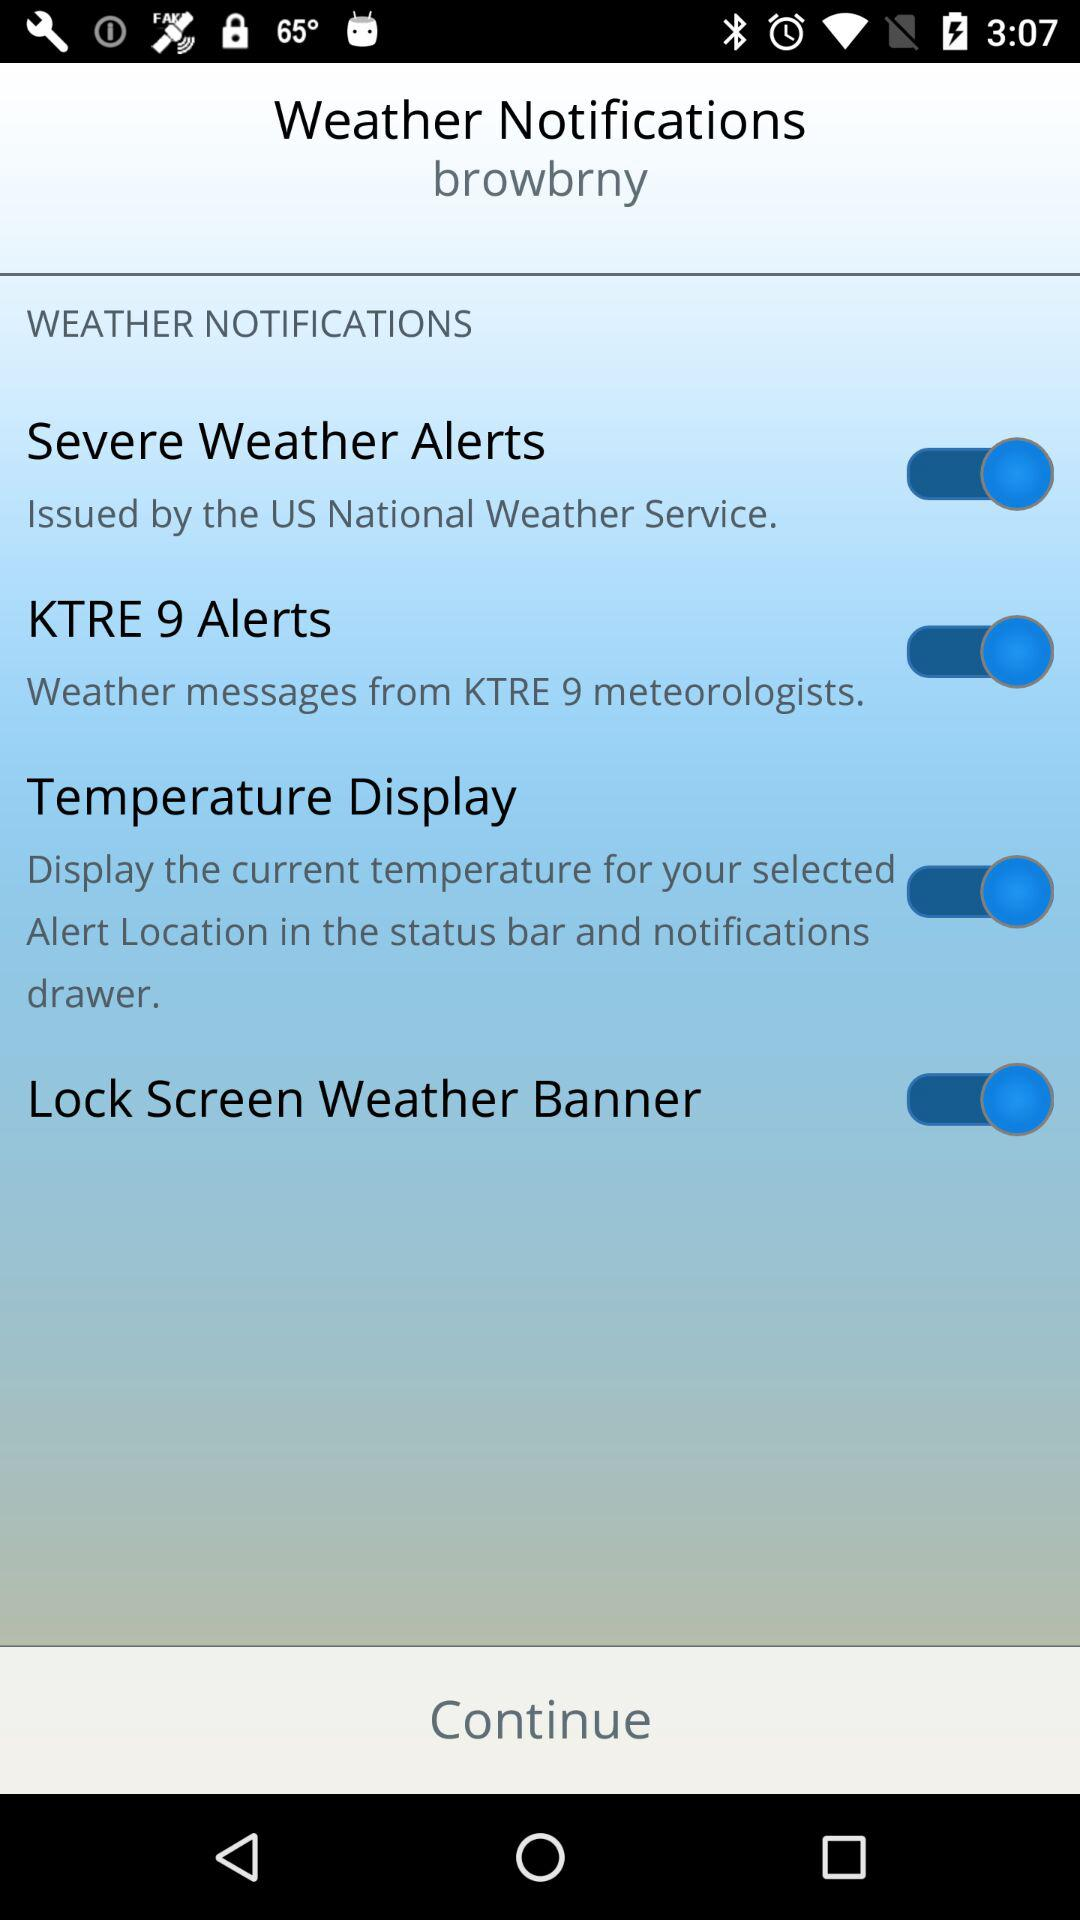What weather service issues severe weather alerts? The severe weather alerts issued by the US National Weather Service. 